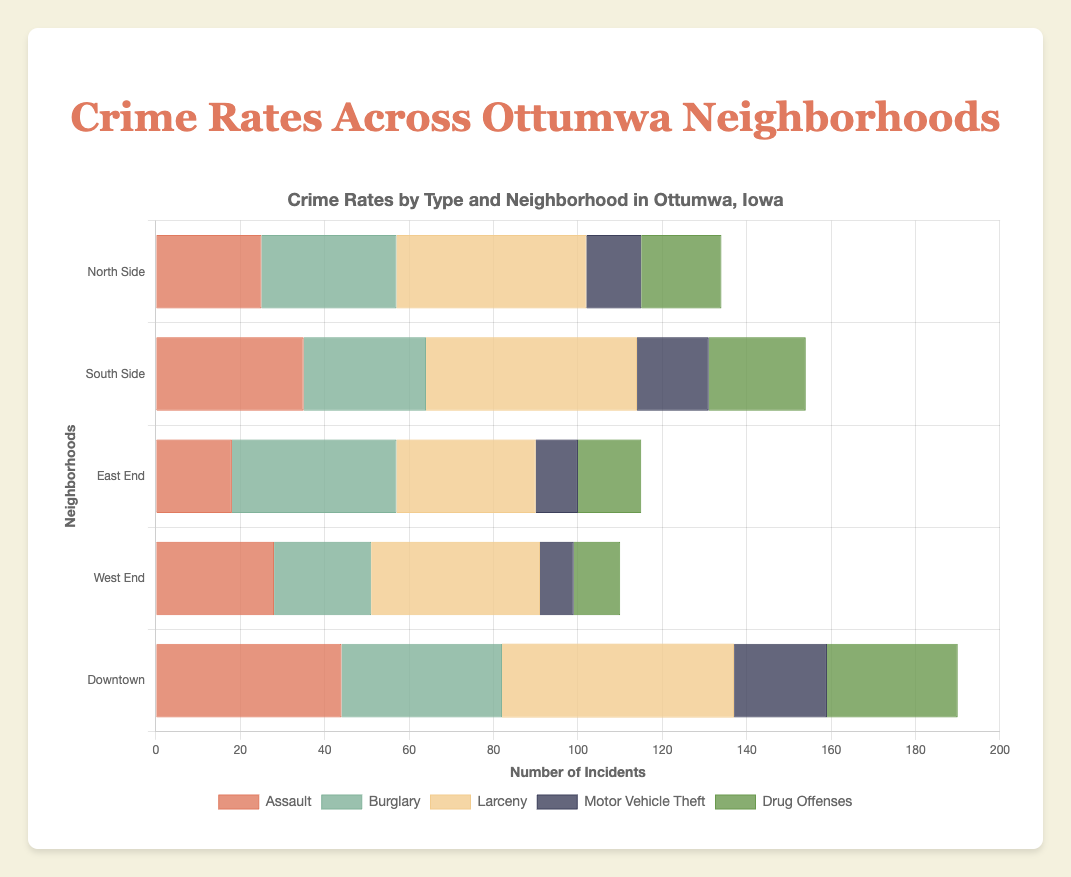Which neighborhood has the highest number of larceny cases? Check the 'Larceny' bars for each neighborhood; find the bar with the greatest length. The Downtown neighborhood has the highest larceny cases with a value of 55.
Answer: Downtown How many total burglary cases are there in Ottumwa? Sum the burglary cases across all neighborhoods: 32 (North Side) + 29 (South Side) + 39 (East End) + 23 (West End) + 38 (Downtown) = 161.
Answer: 161 Which crime type shows the highest incidents in the North Side neighborhood? Look at all the bars for North Side; the bar with 'Larceny' has the highest value of 45.
Answer: Larceny Between South Side and Downtown, which has more assault cases? Compare the 'Assault' bars for South Side (35) and Downtown (44); Downtown has a higher value.
Answer: Downtown What's the average number of motor vehicle thefts across all neighborhoods? Sum the motor vehicle thefts and divide by the number of neighborhoods: (13+17+10+8+22)/5 = 70/5 = 14.
Answer: 14 Which neighborhood has the lowest number of drug offenses? Find the shortest 'Drug Offenses' bar, which belongs to the West End with a value of 11.
Answer: West End Are there more total assault cases or drug offenses in Ottumwa? Sum the assault cases: 25+35+18+28+44 = 150; and drug offenses: 19+23+15+11+31 = 99; assaults have more cases (150 > 99).
Answer: Assault cases How does the number of larceny cases in the West End compare to those in the East End? Compare the 'Larceny' bars for West End (40) and East End (33); the West End has more larceny cases.
Answer: West End What is the sum of drug offenses and larceny cases in the South Side? Add the values for drug offenses (23) and larceny cases (50) in the South Side: 23 + 50 = 73.
Answer: 73 